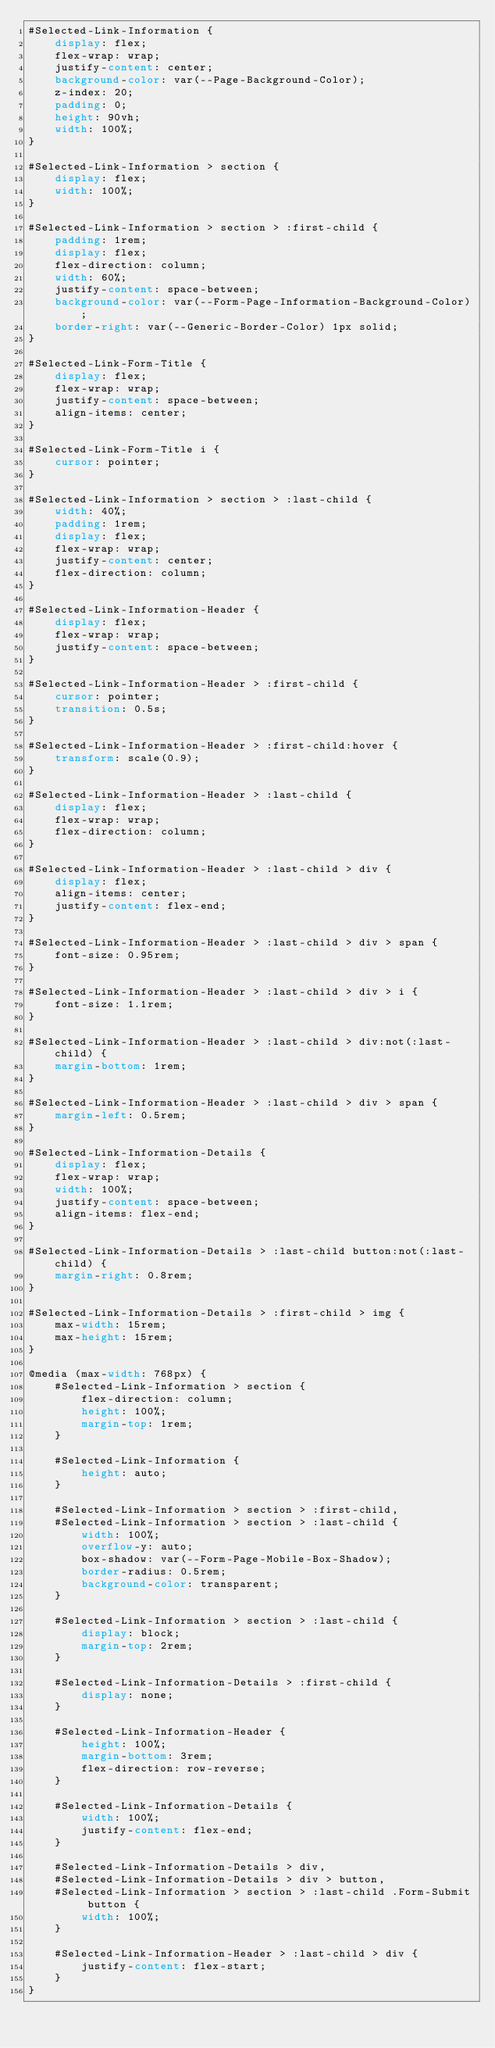<code> <loc_0><loc_0><loc_500><loc_500><_CSS_>#Selected-Link-Information {
    display: flex;
    flex-wrap: wrap;
    justify-content: center;
    background-color: var(--Page-Background-Color);
    z-index: 20;
    padding: 0;
    height: 90vh;
    width: 100%;
}

#Selected-Link-Information > section {
    display: flex;
    width: 100%;
}

#Selected-Link-Information > section > :first-child {
    padding: 1rem;
    display: flex;
    flex-direction: column;
    width: 60%;
    justify-content: space-between;
    background-color: var(--Form-Page-Information-Background-Color);
    border-right: var(--Generic-Border-Color) 1px solid;
}

#Selected-Link-Form-Title {
    display: flex;
    flex-wrap: wrap;
    justify-content: space-between;
    align-items: center;
}

#Selected-Link-Form-Title i {
    cursor: pointer;
}

#Selected-Link-Information > section > :last-child {
    width: 40%;
    padding: 1rem;
    display: flex;
    flex-wrap: wrap;
    justify-content: center;
    flex-direction: column;
}

#Selected-Link-Information-Header {
    display: flex;
    flex-wrap: wrap;
    justify-content: space-between;
}

#Selected-Link-Information-Header > :first-child {
    cursor: pointer;
    transition: 0.5s;
}

#Selected-Link-Information-Header > :first-child:hover {
    transform: scale(0.9);
}

#Selected-Link-Information-Header > :last-child {
    display: flex;
    flex-wrap: wrap;
    flex-direction: column;
}

#Selected-Link-Information-Header > :last-child > div {
    display: flex;
    align-items: center;
    justify-content: flex-end;
}

#Selected-Link-Information-Header > :last-child > div > span {
    font-size: 0.95rem;
}

#Selected-Link-Information-Header > :last-child > div > i {
    font-size: 1.1rem;
}

#Selected-Link-Information-Header > :last-child > div:not(:last-child) {
    margin-bottom: 1rem;
}

#Selected-Link-Information-Header > :last-child > div > span {
    margin-left: 0.5rem;
}

#Selected-Link-Information-Details {
    display: flex;
    flex-wrap: wrap;
    width: 100%;
    justify-content: space-between;
    align-items: flex-end;
}

#Selected-Link-Information-Details > :last-child button:not(:last-child) {
    margin-right: 0.8rem;
}

#Selected-Link-Information-Details > :first-child > img {
    max-width: 15rem;
    max-height: 15rem;
}

@media (max-width: 768px) {
    #Selected-Link-Information > section {
        flex-direction: column;
        height: 100%;
        margin-top: 1rem;
    }

    #Selected-Link-Information {
        height: auto;
    }

    #Selected-Link-Information > section > :first-child,
    #Selected-Link-Information > section > :last-child {
        width: 100%;
        overflow-y: auto;
        box-shadow: var(--Form-Page-Mobile-Box-Shadow);
        border-radius: 0.5rem;
        background-color: transparent;
    }

    #Selected-Link-Information > section > :last-child {
        display: block;
        margin-top: 2rem;
    }

    #Selected-Link-Information-Details > :first-child {
        display: none;
    }

    #Selected-Link-Information-Header {
        height: 100%;
        margin-bottom: 3rem;
        flex-direction: row-reverse;
    }

    #Selected-Link-Information-Details {
        width: 100%;
        justify-content: flex-end;
    }

    #Selected-Link-Information-Details > div,
    #Selected-Link-Information-Details > div > button,
    #Selected-Link-Information > section > :last-child .Form-Submit button {
        width: 100%;
    }

    #Selected-Link-Information-Header > :last-child > div {
        justify-content: flex-start;
    }
}
</code> 